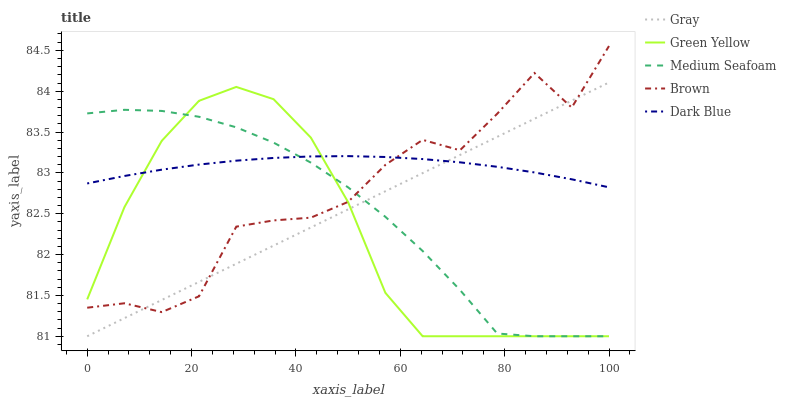Does Green Yellow have the minimum area under the curve?
Answer yes or no. Yes. Does Dark Blue have the maximum area under the curve?
Answer yes or no. Yes. Does Dark Blue have the minimum area under the curve?
Answer yes or no. No. Does Green Yellow have the maximum area under the curve?
Answer yes or no. No. Is Gray the smoothest?
Answer yes or no. Yes. Is Brown the roughest?
Answer yes or no. Yes. Is Dark Blue the smoothest?
Answer yes or no. No. Is Dark Blue the roughest?
Answer yes or no. No. Does Dark Blue have the lowest value?
Answer yes or no. No. Does Green Yellow have the highest value?
Answer yes or no. No. 